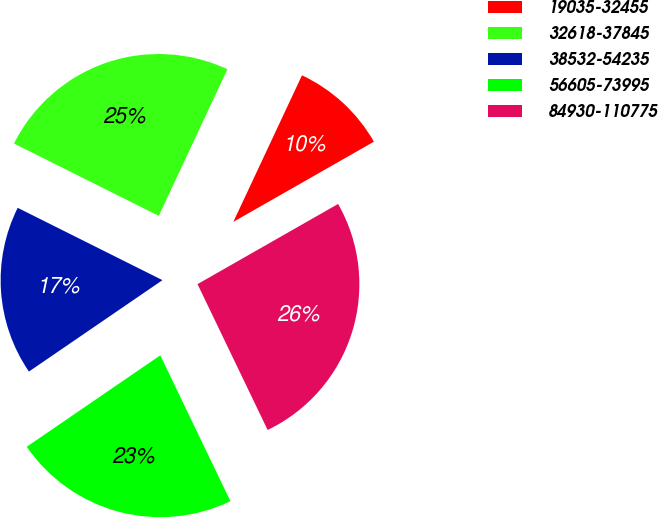<chart> <loc_0><loc_0><loc_500><loc_500><pie_chart><fcel>19035-32455<fcel>32618-37845<fcel>38532-54235<fcel>56605-73995<fcel>84930-110775<nl><fcel>9.78%<fcel>24.6%<fcel>16.93%<fcel>22.58%<fcel>26.12%<nl></chart> 